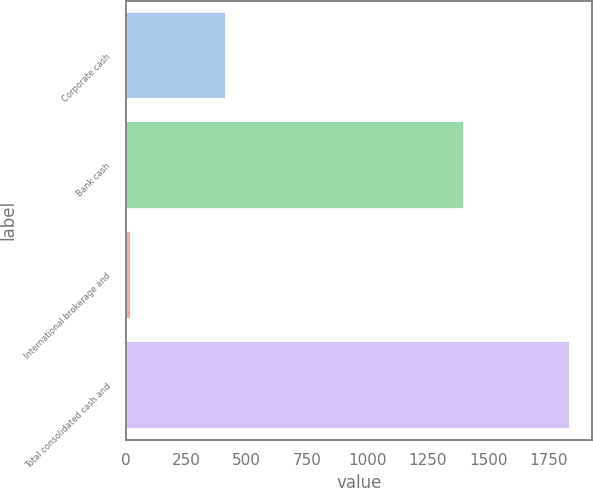Convert chart to OTSL. <chart><loc_0><loc_0><loc_500><loc_500><bar_chart><fcel>Corporate cash<fcel>Bank cash<fcel>International brokerage and<fcel>Total consolidated cash and<nl><fcel>415.1<fcel>1402<fcel>20.9<fcel>1838<nl></chart> 